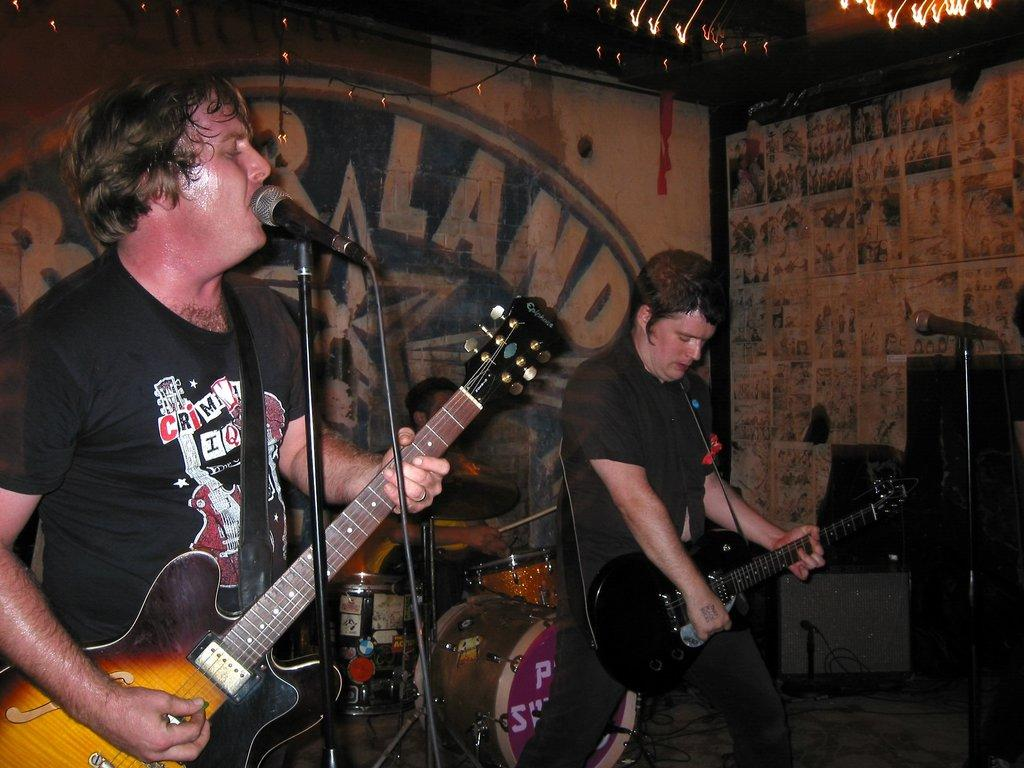How many people are in the image? There are two men in the image. What are the men doing in the image? Both men are playing a guitar. What object is present in front of the men? There is a microphone in front of the men. Can you tell me how many books are visible in the image? There are no books present in the image. What type of harmony can be heard coming from the men in the image? There is no sound or indication of harmony in the image, as it is a still photograph. 